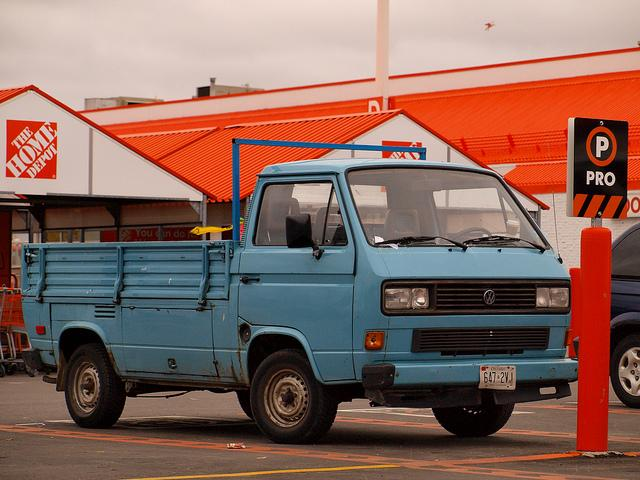What does the store to the left sell?

Choices:
A) hammers
B) donuts
C) sandwiches
D) pizza hammers 